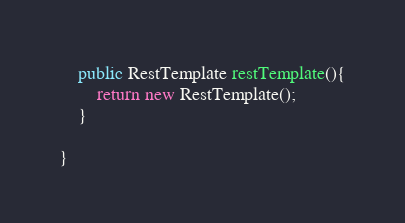<code> <loc_0><loc_0><loc_500><loc_500><_Java_>	public RestTemplate restTemplate(){
		return new RestTemplate();
	}

}
</code> 